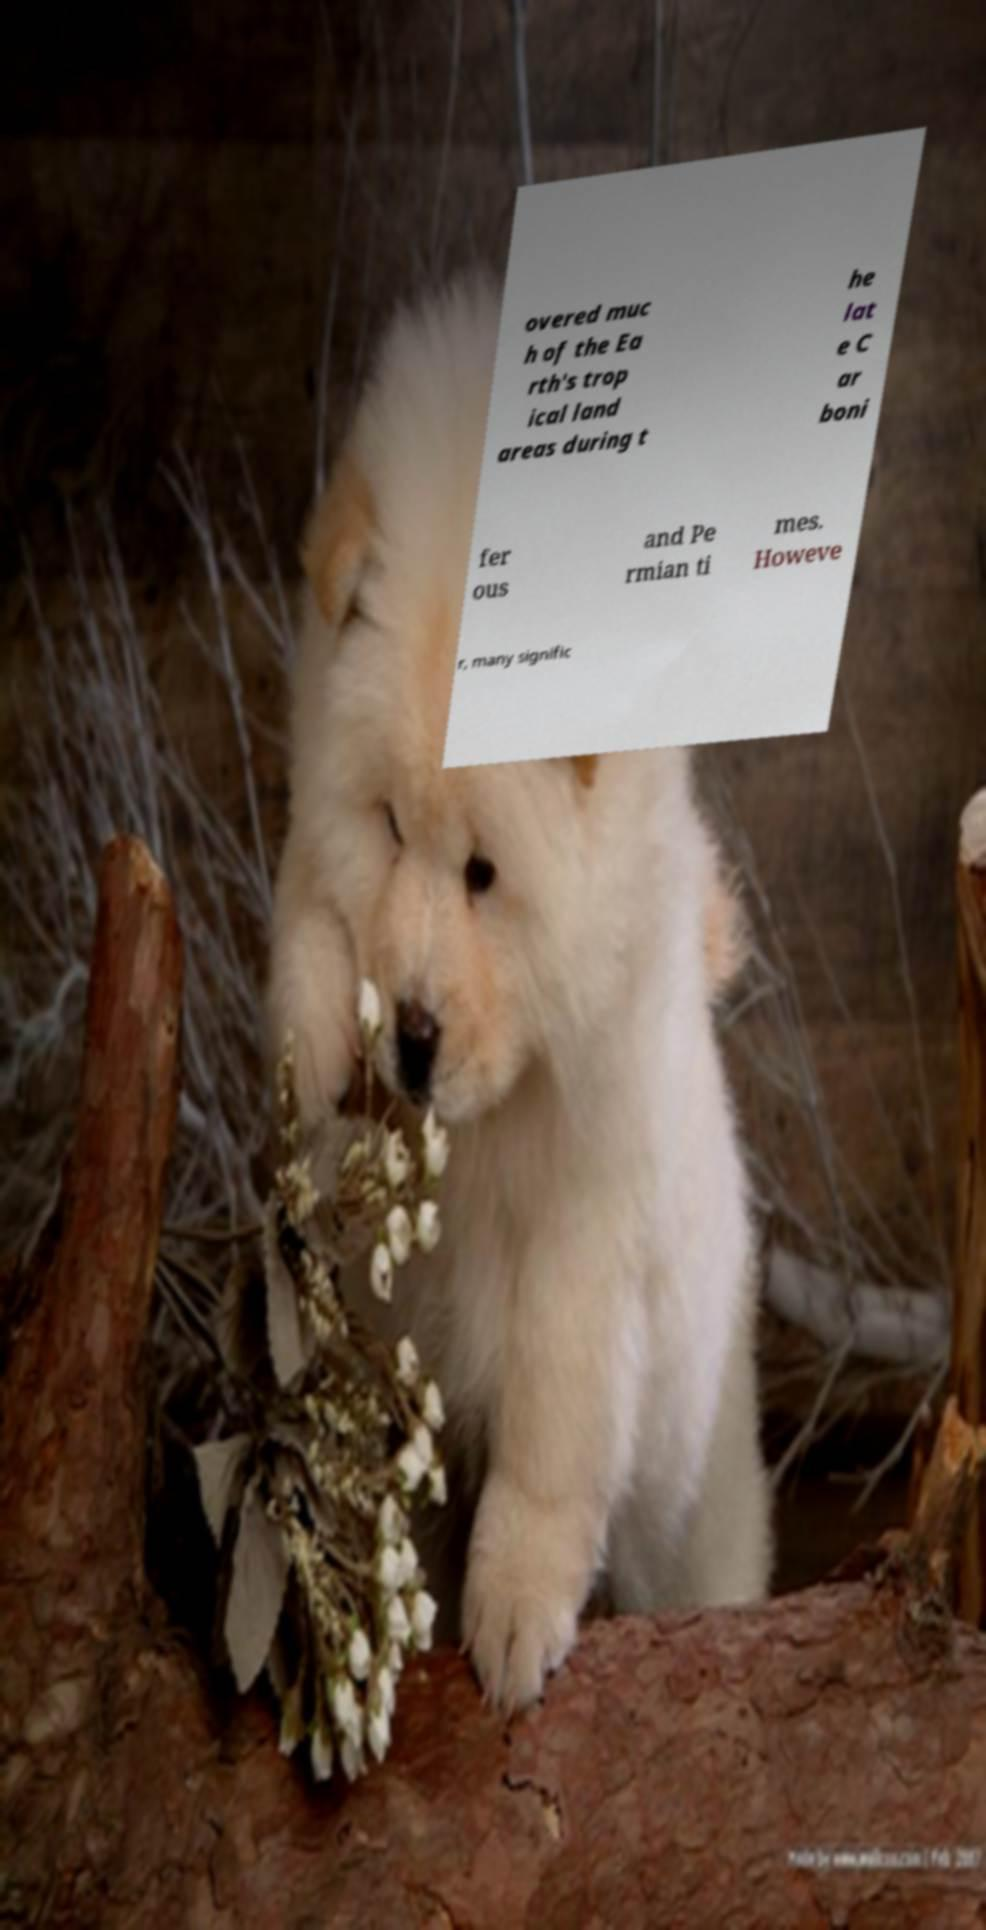Please read and relay the text visible in this image. What does it say? overed muc h of the Ea rth's trop ical land areas during t he lat e C ar boni fer ous and Pe rmian ti mes. Howeve r, many signific 